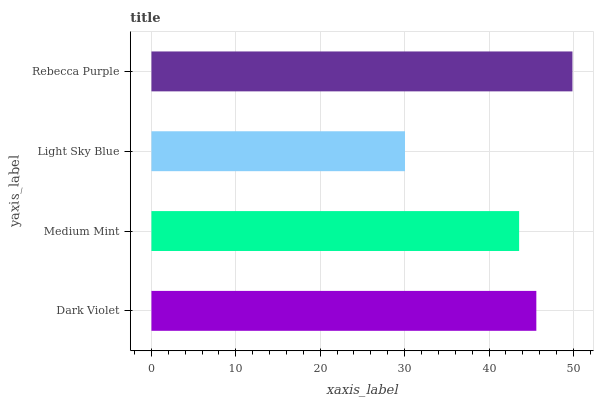Is Light Sky Blue the minimum?
Answer yes or no. Yes. Is Rebecca Purple the maximum?
Answer yes or no. Yes. Is Medium Mint the minimum?
Answer yes or no. No. Is Medium Mint the maximum?
Answer yes or no. No. Is Dark Violet greater than Medium Mint?
Answer yes or no. Yes. Is Medium Mint less than Dark Violet?
Answer yes or no. Yes. Is Medium Mint greater than Dark Violet?
Answer yes or no. No. Is Dark Violet less than Medium Mint?
Answer yes or no. No. Is Dark Violet the high median?
Answer yes or no. Yes. Is Medium Mint the low median?
Answer yes or no. Yes. Is Rebecca Purple the high median?
Answer yes or no. No. Is Light Sky Blue the low median?
Answer yes or no. No. 